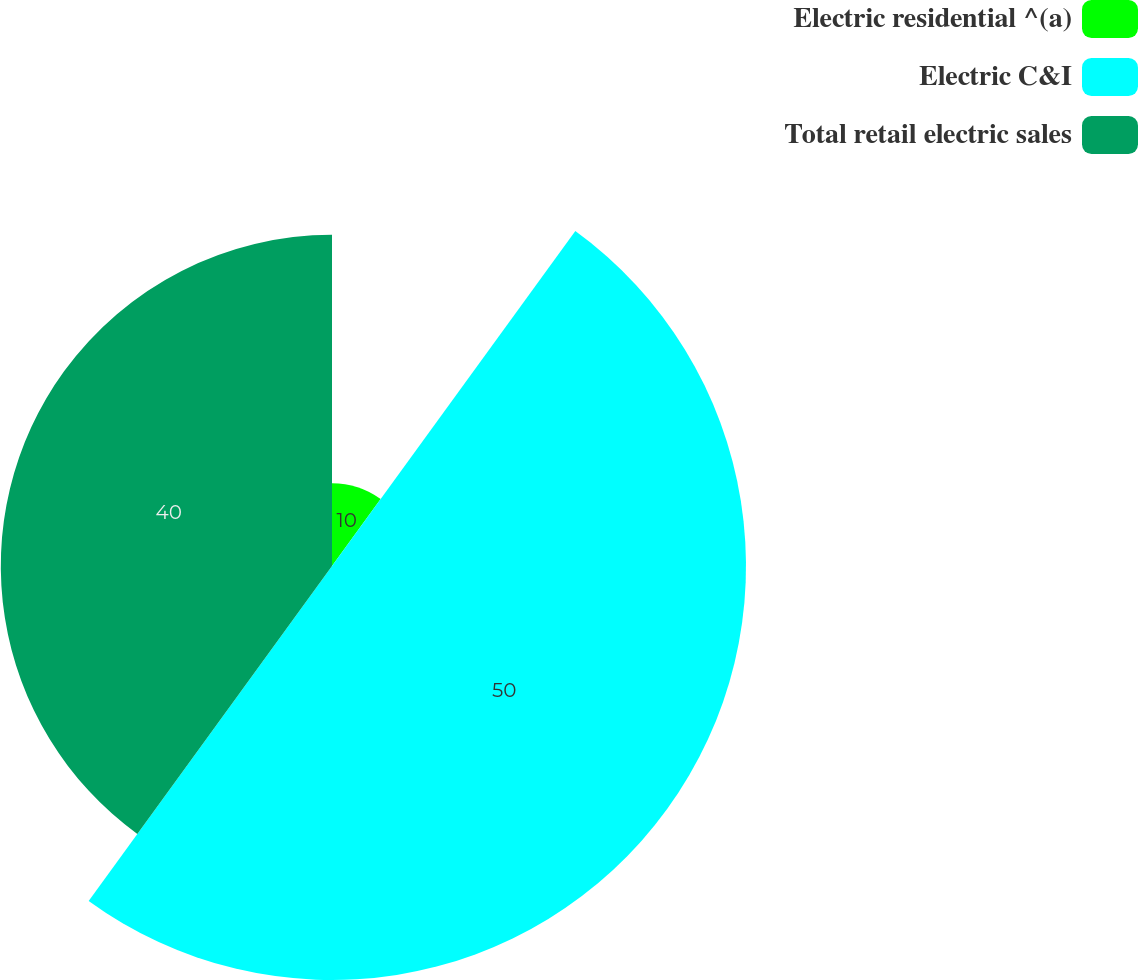Convert chart. <chart><loc_0><loc_0><loc_500><loc_500><pie_chart><fcel>Electric residential ^(a)<fcel>Electric C&I<fcel>Total retail electric sales<nl><fcel>10.0%<fcel>50.0%<fcel>40.0%<nl></chart> 